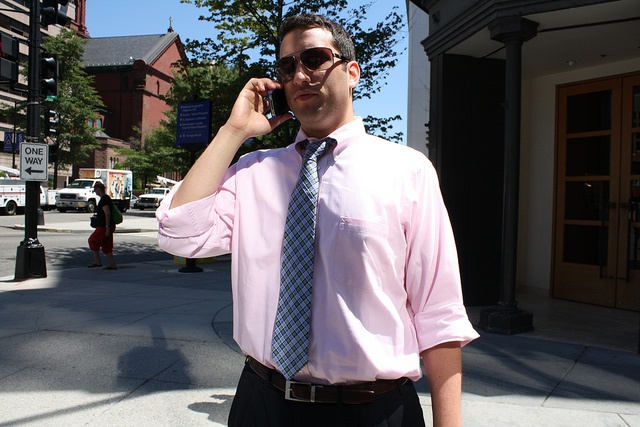Describe the objects in this image and their specific colors. I can see people in black, lavender, gray, and lightpink tones, tie in black, gray, and navy tones, truck in black, white, gray, and darkgray tones, people in black, maroon, gray, and teal tones, and truck in black, lightgray, gray, and darkgray tones in this image. 